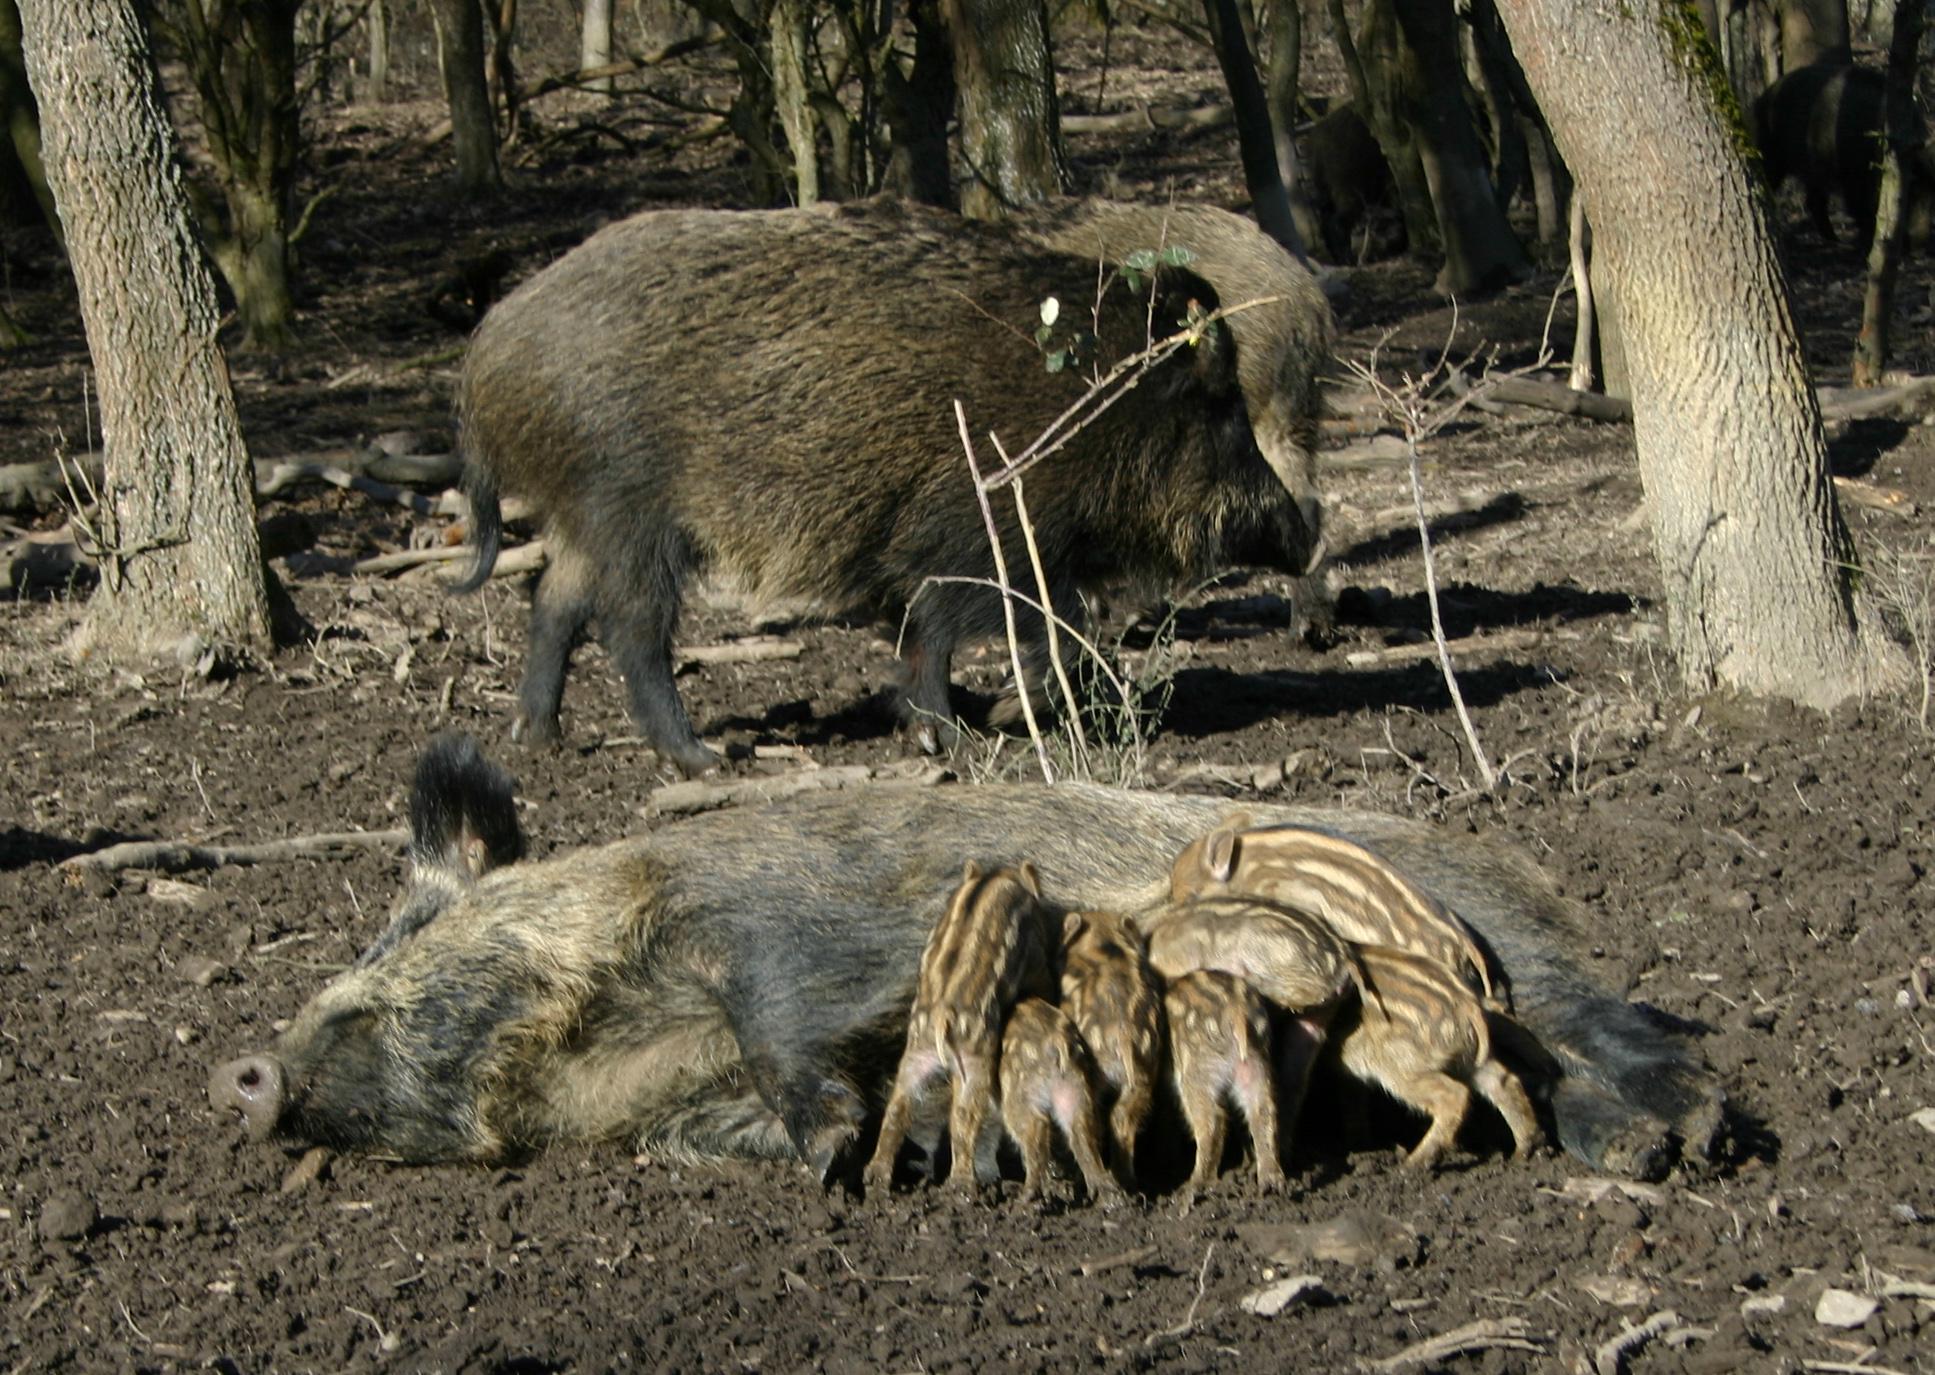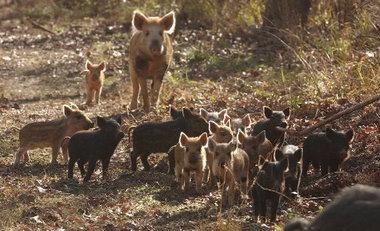The first image is the image on the left, the second image is the image on the right. Analyze the images presented: Is the assertion "There is black mother boar laying the dirt with at least six nursing piglets at her belly." valid? Answer yes or no. Yes. 